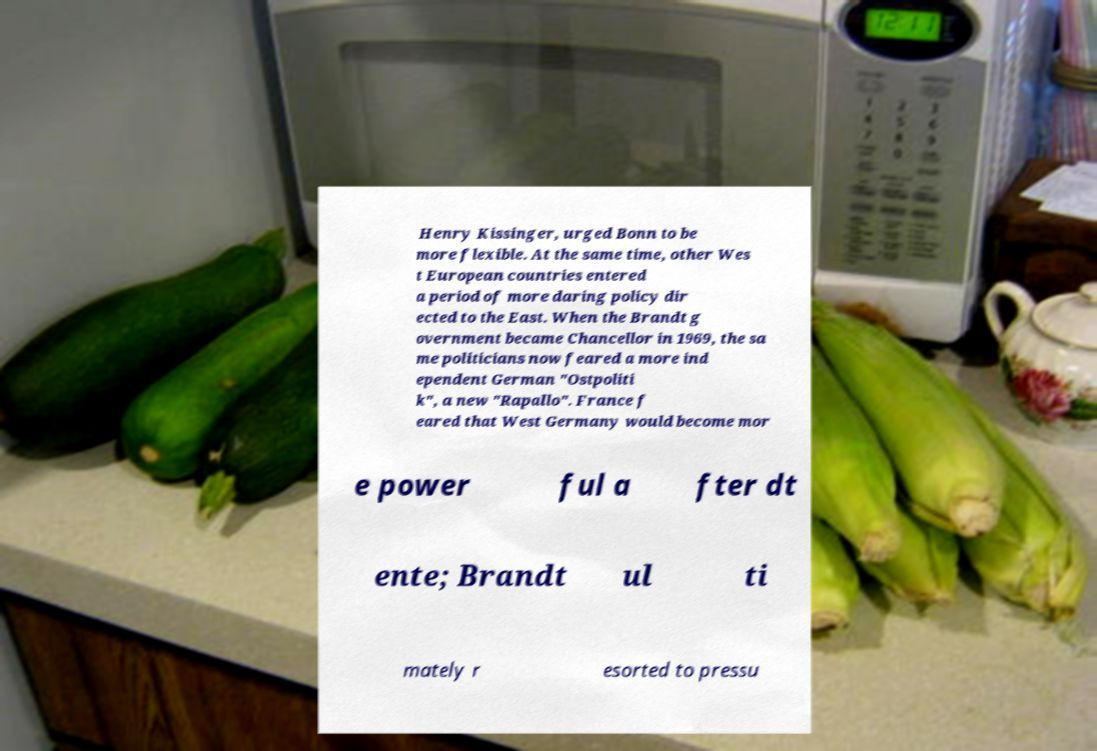Could you assist in decoding the text presented in this image and type it out clearly? Henry Kissinger, urged Bonn to be more flexible. At the same time, other Wes t European countries entered a period of more daring policy dir ected to the East. When the Brandt g overnment became Chancellor in 1969, the sa me politicians now feared a more ind ependent German "Ostpoliti k", a new "Rapallo". France f eared that West Germany would become mor e power ful a fter dt ente; Brandt ul ti mately r esorted to pressu 